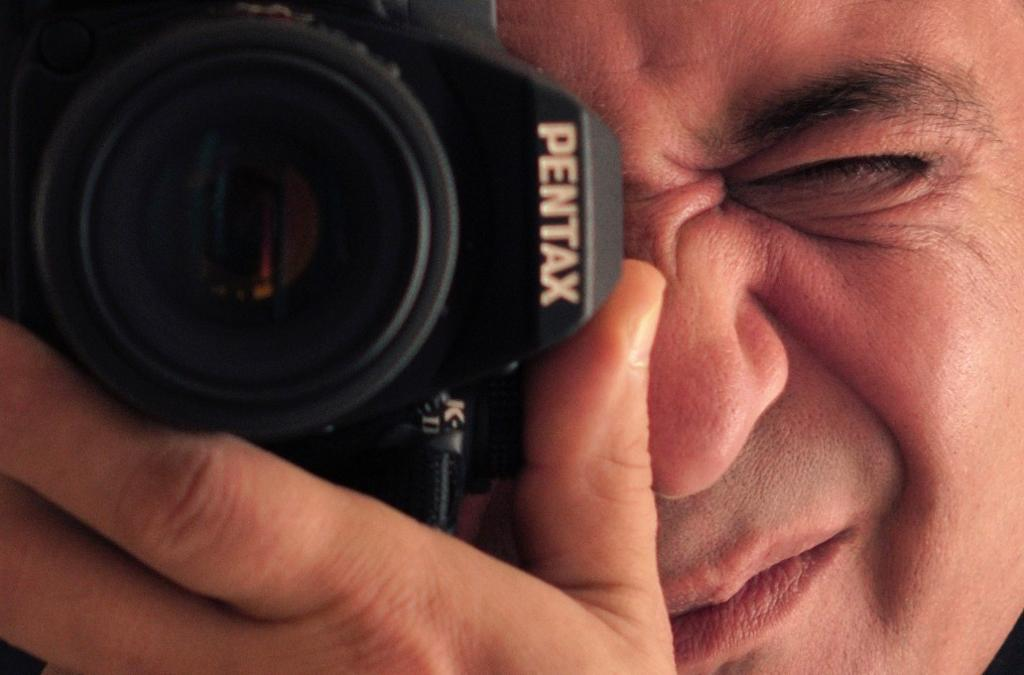What is the main subject of the image? There is a person in the image. What is the person doing in the image? The person is taking a snap with a camera. What type of vegetable is the person holding in the image? There is no vegetable present in the image; the person is holding a camera. 